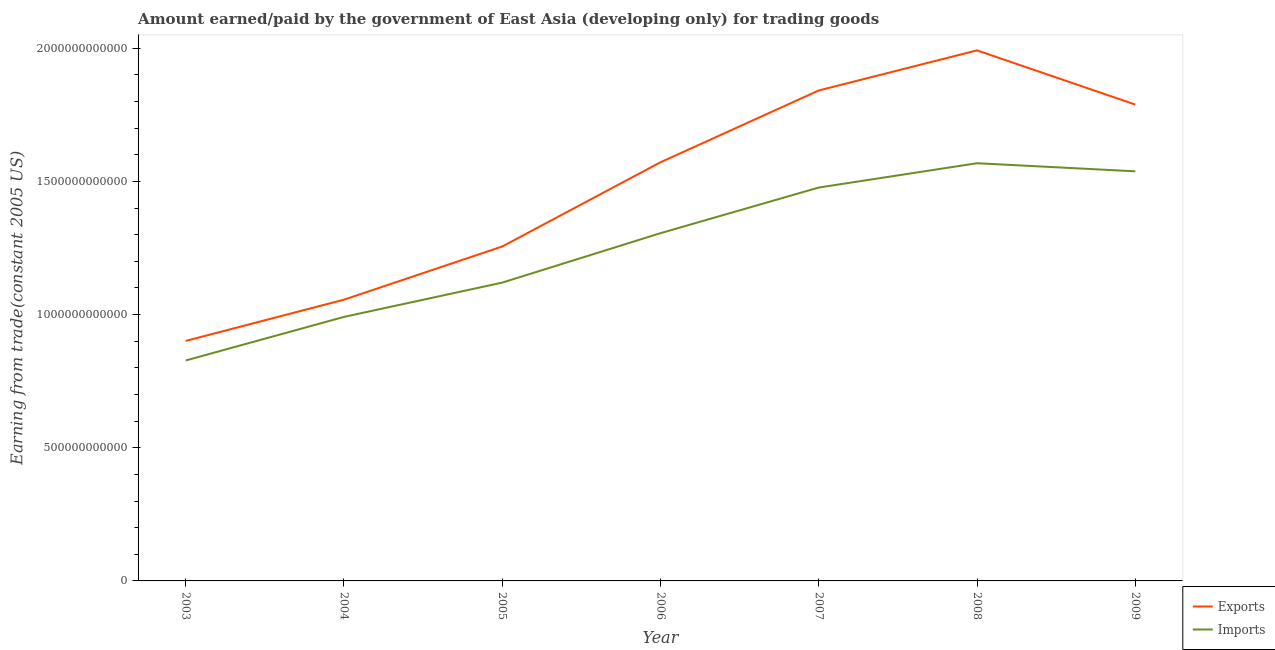Is the number of lines equal to the number of legend labels?
Your response must be concise. Yes. What is the amount paid for imports in 2007?
Keep it short and to the point. 1.48e+12. Across all years, what is the maximum amount earned from exports?
Give a very brief answer. 1.99e+12. Across all years, what is the minimum amount earned from exports?
Offer a very short reply. 9.01e+11. In which year was the amount earned from exports maximum?
Your response must be concise. 2008. What is the total amount earned from exports in the graph?
Make the answer very short. 1.04e+13. What is the difference between the amount paid for imports in 2003 and that in 2006?
Offer a very short reply. -4.78e+11. What is the difference between the amount paid for imports in 2003 and the amount earned from exports in 2009?
Your answer should be compact. -9.61e+11. What is the average amount earned from exports per year?
Provide a succinct answer. 1.49e+12. In the year 2006, what is the difference between the amount earned from exports and amount paid for imports?
Your response must be concise. 2.66e+11. What is the ratio of the amount paid for imports in 2008 to that in 2009?
Your answer should be very brief. 1.02. What is the difference between the highest and the second highest amount earned from exports?
Make the answer very short. 1.50e+11. What is the difference between the highest and the lowest amount paid for imports?
Provide a short and direct response. 7.41e+11. In how many years, is the amount earned from exports greater than the average amount earned from exports taken over all years?
Make the answer very short. 4. How many years are there in the graph?
Your answer should be compact. 7. What is the difference between two consecutive major ticks on the Y-axis?
Offer a very short reply. 5.00e+11. How are the legend labels stacked?
Your answer should be very brief. Vertical. What is the title of the graph?
Ensure brevity in your answer.  Amount earned/paid by the government of East Asia (developing only) for trading goods. What is the label or title of the Y-axis?
Make the answer very short. Earning from trade(constant 2005 US). What is the Earning from trade(constant 2005 US) of Exports in 2003?
Provide a succinct answer. 9.01e+11. What is the Earning from trade(constant 2005 US) in Imports in 2003?
Ensure brevity in your answer.  8.28e+11. What is the Earning from trade(constant 2005 US) in Exports in 2004?
Your answer should be very brief. 1.06e+12. What is the Earning from trade(constant 2005 US) in Imports in 2004?
Offer a very short reply. 9.91e+11. What is the Earning from trade(constant 2005 US) of Exports in 2005?
Provide a succinct answer. 1.26e+12. What is the Earning from trade(constant 2005 US) of Imports in 2005?
Your response must be concise. 1.12e+12. What is the Earning from trade(constant 2005 US) of Exports in 2006?
Keep it short and to the point. 1.57e+12. What is the Earning from trade(constant 2005 US) in Imports in 2006?
Your response must be concise. 1.31e+12. What is the Earning from trade(constant 2005 US) in Exports in 2007?
Provide a short and direct response. 1.84e+12. What is the Earning from trade(constant 2005 US) in Imports in 2007?
Your answer should be compact. 1.48e+12. What is the Earning from trade(constant 2005 US) of Exports in 2008?
Make the answer very short. 1.99e+12. What is the Earning from trade(constant 2005 US) of Imports in 2008?
Your answer should be compact. 1.57e+12. What is the Earning from trade(constant 2005 US) of Exports in 2009?
Keep it short and to the point. 1.79e+12. What is the Earning from trade(constant 2005 US) in Imports in 2009?
Your answer should be very brief. 1.54e+12. Across all years, what is the maximum Earning from trade(constant 2005 US) of Exports?
Provide a short and direct response. 1.99e+12. Across all years, what is the maximum Earning from trade(constant 2005 US) of Imports?
Give a very brief answer. 1.57e+12. Across all years, what is the minimum Earning from trade(constant 2005 US) of Exports?
Make the answer very short. 9.01e+11. Across all years, what is the minimum Earning from trade(constant 2005 US) in Imports?
Provide a succinct answer. 8.28e+11. What is the total Earning from trade(constant 2005 US) of Exports in the graph?
Offer a terse response. 1.04e+13. What is the total Earning from trade(constant 2005 US) in Imports in the graph?
Ensure brevity in your answer.  8.83e+12. What is the difference between the Earning from trade(constant 2005 US) in Exports in 2003 and that in 2004?
Your answer should be compact. -1.55e+11. What is the difference between the Earning from trade(constant 2005 US) in Imports in 2003 and that in 2004?
Your answer should be very brief. -1.64e+11. What is the difference between the Earning from trade(constant 2005 US) of Exports in 2003 and that in 2005?
Offer a terse response. -3.55e+11. What is the difference between the Earning from trade(constant 2005 US) of Imports in 2003 and that in 2005?
Provide a succinct answer. -2.92e+11. What is the difference between the Earning from trade(constant 2005 US) in Exports in 2003 and that in 2006?
Make the answer very short. -6.71e+11. What is the difference between the Earning from trade(constant 2005 US) in Imports in 2003 and that in 2006?
Ensure brevity in your answer.  -4.78e+11. What is the difference between the Earning from trade(constant 2005 US) of Exports in 2003 and that in 2007?
Your response must be concise. -9.40e+11. What is the difference between the Earning from trade(constant 2005 US) of Imports in 2003 and that in 2007?
Your response must be concise. -6.49e+11. What is the difference between the Earning from trade(constant 2005 US) in Exports in 2003 and that in 2008?
Ensure brevity in your answer.  -1.09e+12. What is the difference between the Earning from trade(constant 2005 US) of Imports in 2003 and that in 2008?
Keep it short and to the point. -7.41e+11. What is the difference between the Earning from trade(constant 2005 US) in Exports in 2003 and that in 2009?
Offer a terse response. -8.88e+11. What is the difference between the Earning from trade(constant 2005 US) in Imports in 2003 and that in 2009?
Provide a succinct answer. -7.10e+11. What is the difference between the Earning from trade(constant 2005 US) in Exports in 2004 and that in 2005?
Give a very brief answer. -2.00e+11. What is the difference between the Earning from trade(constant 2005 US) in Imports in 2004 and that in 2005?
Provide a short and direct response. -1.29e+11. What is the difference between the Earning from trade(constant 2005 US) of Exports in 2004 and that in 2006?
Provide a succinct answer. -5.16e+11. What is the difference between the Earning from trade(constant 2005 US) of Imports in 2004 and that in 2006?
Your answer should be very brief. -3.14e+11. What is the difference between the Earning from trade(constant 2005 US) of Exports in 2004 and that in 2007?
Your answer should be very brief. -7.86e+11. What is the difference between the Earning from trade(constant 2005 US) of Imports in 2004 and that in 2007?
Give a very brief answer. -4.86e+11. What is the difference between the Earning from trade(constant 2005 US) of Exports in 2004 and that in 2008?
Provide a succinct answer. -9.36e+11. What is the difference between the Earning from trade(constant 2005 US) in Imports in 2004 and that in 2008?
Make the answer very short. -5.77e+11. What is the difference between the Earning from trade(constant 2005 US) in Exports in 2004 and that in 2009?
Your answer should be very brief. -7.33e+11. What is the difference between the Earning from trade(constant 2005 US) in Imports in 2004 and that in 2009?
Ensure brevity in your answer.  -5.47e+11. What is the difference between the Earning from trade(constant 2005 US) in Exports in 2005 and that in 2006?
Provide a short and direct response. -3.16e+11. What is the difference between the Earning from trade(constant 2005 US) in Imports in 2005 and that in 2006?
Provide a succinct answer. -1.86e+11. What is the difference between the Earning from trade(constant 2005 US) of Exports in 2005 and that in 2007?
Provide a succinct answer. -5.86e+11. What is the difference between the Earning from trade(constant 2005 US) in Imports in 2005 and that in 2007?
Offer a very short reply. -3.57e+11. What is the difference between the Earning from trade(constant 2005 US) in Exports in 2005 and that in 2008?
Provide a succinct answer. -7.36e+11. What is the difference between the Earning from trade(constant 2005 US) of Imports in 2005 and that in 2008?
Keep it short and to the point. -4.48e+11. What is the difference between the Earning from trade(constant 2005 US) of Exports in 2005 and that in 2009?
Ensure brevity in your answer.  -5.33e+11. What is the difference between the Earning from trade(constant 2005 US) of Imports in 2005 and that in 2009?
Keep it short and to the point. -4.18e+11. What is the difference between the Earning from trade(constant 2005 US) of Exports in 2006 and that in 2007?
Keep it short and to the point. -2.70e+11. What is the difference between the Earning from trade(constant 2005 US) of Imports in 2006 and that in 2007?
Give a very brief answer. -1.71e+11. What is the difference between the Earning from trade(constant 2005 US) in Exports in 2006 and that in 2008?
Provide a short and direct response. -4.20e+11. What is the difference between the Earning from trade(constant 2005 US) in Imports in 2006 and that in 2008?
Offer a terse response. -2.63e+11. What is the difference between the Earning from trade(constant 2005 US) in Exports in 2006 and that in 2009?
Offer a terse response. -2.17e+11. What is the difference between the Earning from trade(constant 2005 US) of Imports in 2006 and that in 2009?
Keep it short and to the point. -2.32e+11. What is the difference between the Earning from trade(constant 2005 US) in Exports in 2007 and that in 2008?
Make the answer very short. -1.50e+11. What is the difference between the Earning from trade(constant 2005 US) in Imports in 2007 and that in 2008?
Your response must be concise. -9.13e+1. What is the difference between the Earning from trade(constant 2005 US) in Exports in 2007 and that in 2009?
Your answer should be compact. 5.29e+1. What is the difference between the Earning from trade(constant 2005 US) in Imports in 2007 and that in 2009?
Provide a short and direct response. -6.09e+1. What is the difference between the Earning from trade(constant 2005 US) of Exports in 2008 and that in 2009?
Provide a succinct answer. 2.03e+11. What is the difference between the Earning from trade(constant 2005 US) of Imports in 2008 and that in 2009?
Your answer should be compact. 3.04e+1. What is the difference between the Earning from trade(constant 2005 US) of Exports in 2003 and the Earning from trade(constant 2005 US) of Imports in 2004?
Offer a terse response. -9.02e+1. What is the difference between the Earning from trade(constant 2005 US) in Exports in 2003 and the Earning from trade(constant 2005 US) in Imports in 2005?
Your answer should be very brief. -2.19e+11. What is the difference between the Earning from trade(constant 2005 US) of Exports in 2003 and the Earning from trade(constant 2005 US) of Imports in 2006?
Your answer should be very brief. -4.05e+11. What is the difference between the Earning from trade(constant 2005 US) in Exports in 2003 and the Earning from trade(constant 2005 US) in Imports in 2007?
Provide a short and direct response. -5.76e+11. What is the difference between the Earning from trade(constant 2005 US) of Exports in 2003 and the Earning from trade(constant 2005 US) of Imports in 2008?
Keep it short and to the point. -6.67e+11. What is the difference between the Earning from trade(constant 2005 US) in Exports in 2003 and the Earning from trade(constant 2005 US) in Imports in 2009?
Give a very brief answer. -6.37e+11. What is the difference between the Earning from trade(constant 2005 US) of Exports in 2004 and the Earning from trade(constant 2005 US) of Imports in 2005?
Your response must be concise. -6.41e+1. What is the difference between the Earning from trade(constant 2005 US) in Exports in 2004 and the Earning from trade(constant 2005 US) in Imports in 2006?
Your response must be concise. -2.50e+11. What is the difference between the Earning from trade(constant 2005 US) in Exports in 2004 and the Earning from trade(constant 2005 US) in Imports in 2007?
Provide a short and direct response. -4.21e+11. What is the difference between the Earning from trade(constant 2005 US) of Exports in 2004 and the Earning from trade(constant 2005 US) of Imports in 2008?
Make the answer very short. -5.12e+11. What is the difference between the Earning from trade(constant 2005 US) in Exports in 2004 and the Earning from trade(constant 2005 US) in Imports in 2009?
Offer a very short reply. -4.82e+11. What is the difference between the Earning from trade(constant 2005 US) of Exports in 2005 and the Earning from trade(constant 2005 US) of Imports in 2006?
Provide a succinct answer. -5.01e+1. What is the difference between the Earning from trade(constant 2005 US) in Exports in 2005 and the Earning from trade(constant 2005 US) in Imports in 2007?
Provide a short and direct response. -2.21e+11. What is the difference between the Earning from trade(constant 2005 US) of Exports in 2005 and the Earning from trade(constant 2005 US) of Imports in 2008?
Your answer should be very brief. -3.13e+11. What is the difference between the Earning from trade(constant 2005 US) of Exports in 2005 and the Earning from trade(constant 2005 US) of Imports in 2009?
Give a very brief answer. -2.82e+11. What is the difference between the Earning from trade(constant 2005 US) of Exports in 2006 and the Earning from trade(constant 2005 US) of Imports in 2007?
Your answer should be very brief. 9.49e+1. What is the difference between the Earning from trade(constant 2005 US) of Exports in 2006 and the Earning from trade(constant 2005 US) of Imports in 2008?
Your response must be concise. 3.58e+09. What is the difference between the Earning from trade(constant 2005 US) of Exports in 2006 and the Earning from trade(constant 2005 US) of Imports in 2009?
Provide a short and direct response. 3.40e+1. What is the difference between the Earning from trade(constant 2005 US) in Exports in 2007 and the Earning from trade(constant 2005 US) in Imports in 2008?
Make the answer very short. 2.73e+11. What is the difference between the Earning from trade(constant 2005 US) of Exports in 2007 and the Earning from trade(constant 2005 US) of Imports in 2009?
Your answer should be very brief. 3.04e+11. What is the difference between the Earning from trade(constant 2005 US) in Exports in 2008 and the Earning from trade(constant 2005 US) in Imports in 2009?
Offer a very short reply. 4.54e+11. What is the average Earning from trade(constant 2005 US) of Exports per year?
Offer a terse response. 1.49e+12. What is the average Earning from trade(constant 2005 US) in Imports per year?
Your answer should be compact. 1.26e+12. In the year 2003, what is the difference between the Earning from trade(constant 2005 US) in Exports and Earning from trade(constant 2005 US) in Imports?
Your answer should be very brief. 7.35e+1. In the year 2004, what is the difference between the Earning from trade(constant 2005 US) of Exports and Earning from trade(constant 2005 US) of Imports?
Ensure brevity in your answer.  6.47e+1. In the year 2005, what is the difference between the Earning from trade(constant 2005 US) of Exports and Earning from trade(constant 2005 US) of Imports?
Provide a succinct answer. 1.36e+11. In the year 2006, what is the difference between the Earning from trade(constant 2005 US) in Exports and Earning from trade(constant 2005 US) in Imports?
Offer a very short reply. 2.66e+11. In the year 2007, what is the difference between the Earning from trade(constant 2005 US) in Exports and Earning from trade(constant 2005 US) in Imports?
Your answer should be very brief. 3.65e+11. In the year 2008, what is the difference between the Earning from trade(constant 2005 US) in Exports and Earning from trade(constant 2005 US) in Imports?
Give a very brief answer. 4.24e+11. In the year 2009, what is the difference between the Earning from trade(constant 2005 US) in Exports and Earning from trade(constant 2005 US) in Imports?
Your answer should be very brief. 2.51e+11. What is the ratio of the Earning from trade(constant 2005 US) in Exports in 2003 to that in 2004?
Make the answer very short. 0.85. What is the ratio of the Earning from trade(constant 2005 US) in Imports in 2003 to that in 2004?
Your answer should be very brief. 0.83. What is the ratio of the Earning from trade(constant 2005 US) in Exports in 2003 to that in 2005?
Your answer should be very brief. 0.72. What is the ratio of the Earning from trade(constant 2005 US) in Imports in 2003 to that in 2005?
Offer a terse response. 0.74. What is the ratio of the Earning from trade(constant 2005 US) of Exports in 2003 to that in 2006?
Provide a short and direct response. 0.57. What is the ratio of the Earning from trade(constant 2005 US) of Imports in 2003 to that in 2006?
Offer a very short reply. 0.63. What is the ratio of the Earning from trade(constant 2005 US) in Exports in 2003 to that in 2007?
Your answer should be compact. 0.49. What is the ratio of the Earning from trade(constant 2005 US) in Imports in 2003 to that in 2007?
Make the answer very short. 0.56. What is the ratio of the Earning from trade(constant 2005 US) in Exports in 2003 to that in 2008?
Make the answer very short. 0.45. What is the ratio of the Earning from trade(constant 2005 US) in Imports in 2003 to that in 2008?
Your answer should be very brief. 0.53. What is the ratio of the Earning from trade(constant 2005 US) in Exports in 2003 to that in 2009?
Your answer should be compact. 0.5. What is the ratio of the Earning from trade(constant 2005 US) of Imports in 2003 to that in 2009?
Provide a short and direct response. 0.54. What is the ratio of the Earning from trade(constant 2005 US) in Exports in 2004 to that in 2005?
Make the answer very short. 0.84. What is the ratio of the Earning from trade(constant 2005 US) of Imports in 2004 to that in 2005?
Your answer should be very brief. 0.89. What is the ratio of the Earning from trade(constant 2005 US) in Exports in 2004 to that in 2006?
Offer a terse response. 0.67. What is the ratio of the Earning from trade(constant 2005 US) in Imports in 2004 to that in 2006?
Offer a terse response. 0.76. What is the ratio of the Earning from trade(constant 2005 US) in Exports in 2004 to that in 2007?
Keep it short and to the point. 0.57. What is the ratio of the Earning from trade(constant 2005 US) of Imports in 2004 to that in 2007?
Offer a very short reply. 0.67. What is the ratio of the Earning from trade(constant 2005 US) of Exports in 2004 to that in 2008?
Offer a very short reply. 0.53. What is the ratio of the Earning from trade(constant 2005 US) of Imports in 2004 to that in 2008?
Keep it short and to the point. 0.63. What is the ratio of the Earning from trade(constant 2005 US) in Exports in 2004 to that in 2009?
Provide a succinct answer. 0.59. What is the ratio of the Earning from trade(constant 2005 US) of Imports in 2004 to that in 2009?
Your answer should be compact. 0.64. What is the ratio of the Earning from trade(constant 2005 US) of Exports in 2005 to that in 2006?
Provide a succinct answer. 0.8. What is the ratio of the Earning from trade(constant 2005 US) in Imports in 2005 to that in 2006?
Give a very brief answer. 0.86. What is the ratio of the Earning from trade(constant 2005 US) in Exports in 2005 to that in 2007?
Keep it short and to the point. 0.68. What is the ratio of the Earning from trade(constant 2005 US) of Imports in 2005 to that in 2007?
Provide a succinct answer. 0.76. What is the ratio of the Earning from trade(constant 2005 US) in Exports in 2005 to that in 2008?
Your response must be concise. 0.63. What is the ratio of the Earning from trade(constant 2005 US) of Imports in 2005 to that in 2008?
Your answer should be very brief. 0.71. What is the ratio of the Earning from trade(constant 2005 US) of Exports in 2005 to that in 2009?
Give a very brief answer. 0.7. What is the ratio of the Earning from trade(constant 2005 US) in Imports in 2005 to that in 2009?
Keep it short and to the point. 0.73. What is the ratio of the Earning from trade(constant 2005 US) in Exports in 2006 to that in 2007?
Make the answer very short. 0.85. What is the ratio of the Earning from trade(constant 2005 US) in Imports in 2006 to that in 2007?
Provide a short and direct response. 0.88. What is the ratio of the Earning from trade(constant 2005 US) of Exports in 2006 to that in 2008?
Ensure brevity in your answer.  0.79. What is the ratio of the Earning from trade(constant 2005 US) in Imports in 2006 to that in 2008?
Your answer should be compact. 0.83. What is the ratio of the Earning from trade(constant 2005 US) in Exports in 2006 to that in 2009?
Ensure brevity in your answer.  0.88. What is the ratio of the Earning from trade(constant 2005 US) in Imports in 2006 to that in 2009?
Give a very brief answer. 0.85. What is the ratio of the Earning from trade(constant 2005 US) of Exports in 2007 to that in 2008?
Offer a very short reply. 0.92. What is the ratio of the Earning from trade(constant 2005 US) in Imports in 2007 to that in 2008?
Your answer should be compact. 0.94. What is the ratio of the Earning from trade(constant 2005 US) of Exports in 2007 to that in 2009?
Keep it short and to the point. 1.03. What is the ratio of the Earning from trade(constant 2005 US) in Imports in 2007 to that in 2009?
Provide a succinct answer. 0.96. What is the ratio of the Earning from trade(constant 2005 US) of Exports in 2008 to that in 2009?
Provide a succinct answer. 1.11. What is the ratio of the Earning from trade(constant 2005 US) in Imports in 2008 to that in 2009?
Keep it short and to the point. 1.02. What is the difference between the highest and the second highest Earning from trade(constant 2005 US) of Exports?
Make the answer very short. 1.50e+11. What is the difference between the highest and the second highest Earning from trade(constant 2005 US) in Imports?
Offer a terse response. 3.04e+1. What is the difference between the highest and the lowest Earning from trade(constant 2005 US) of Exports?
Your answer should be very brief. 1.09e+12. What is the difference between the highest and the lowest Earning from trade(constant 2005 US) of Imports?
Give a very brief answer. 7.41e+11. 